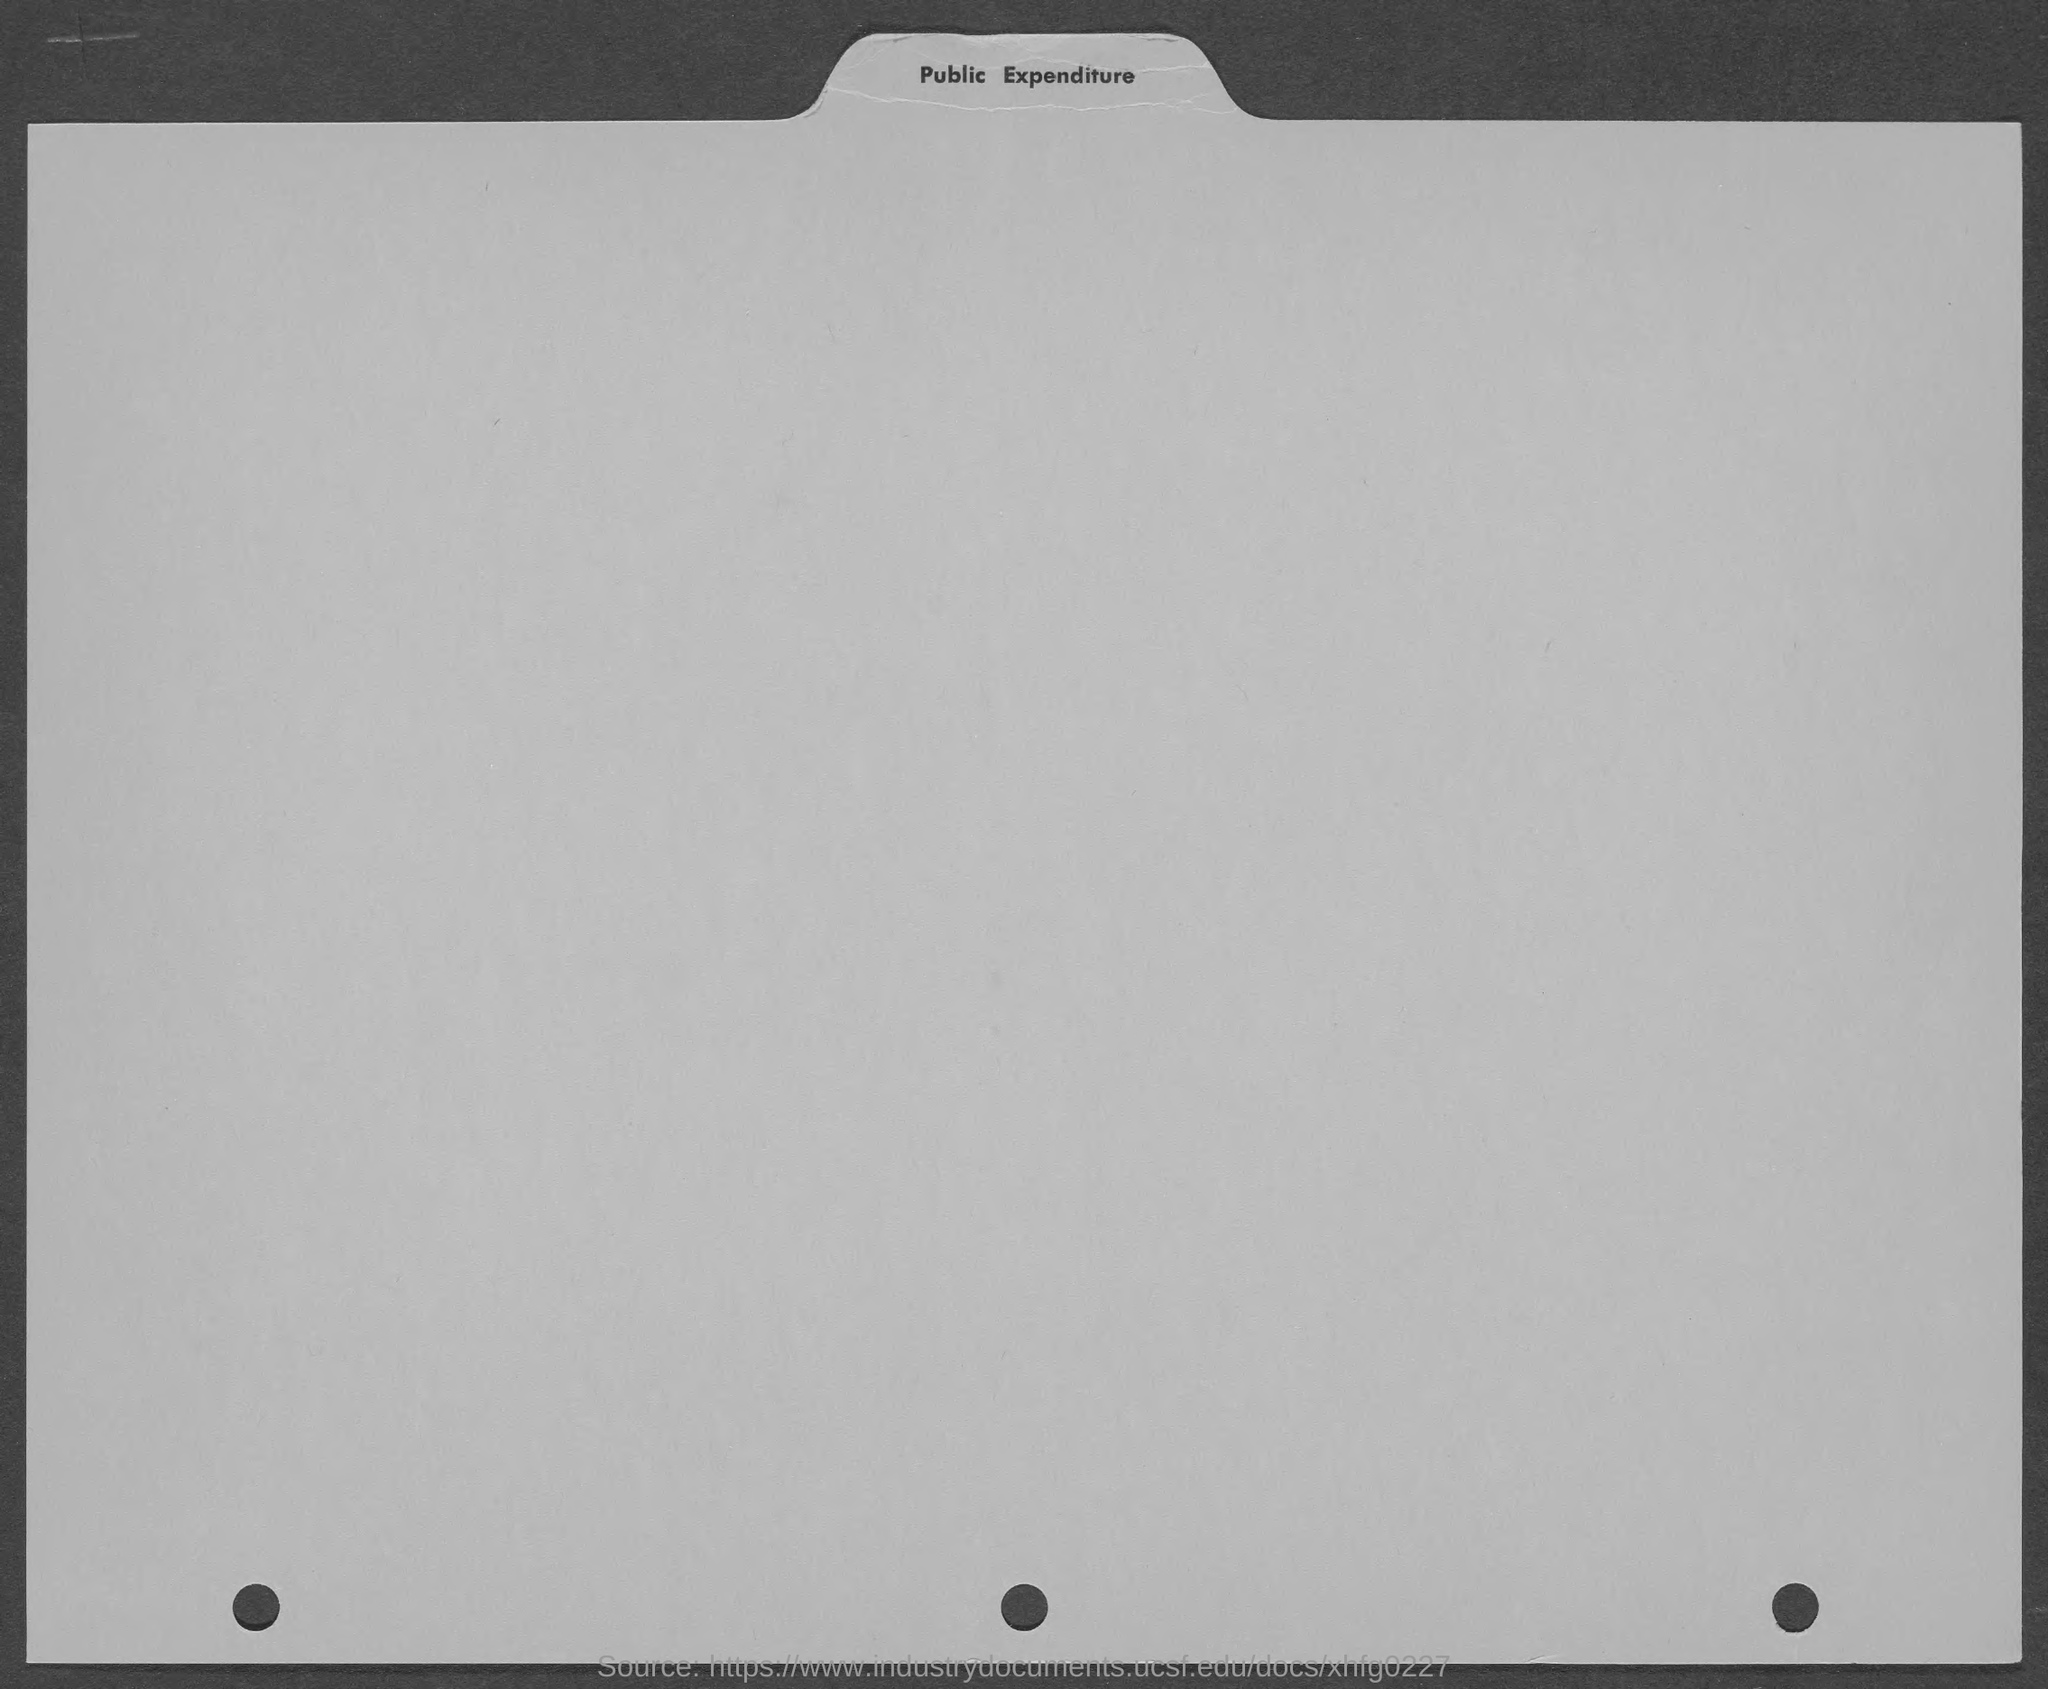What is the heading of the page?
Make the answer very short. Public Expenditure. 